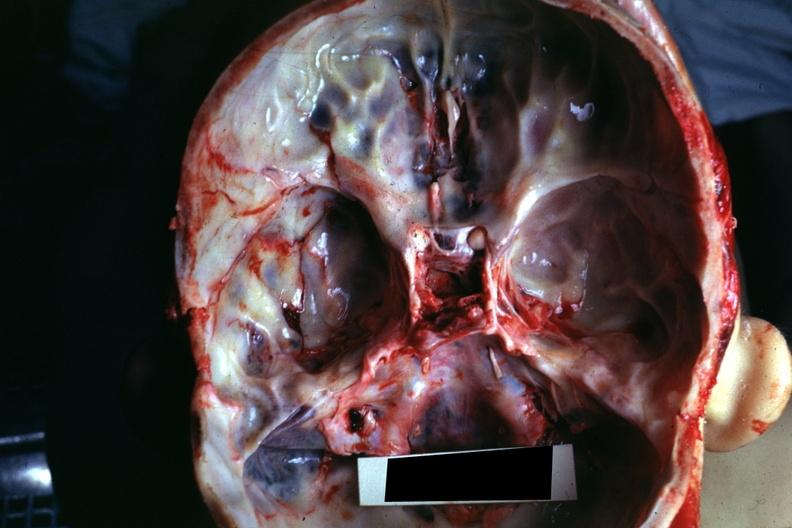what is present?
Answer the question using a single word or phrase. Basilar skull fracture 